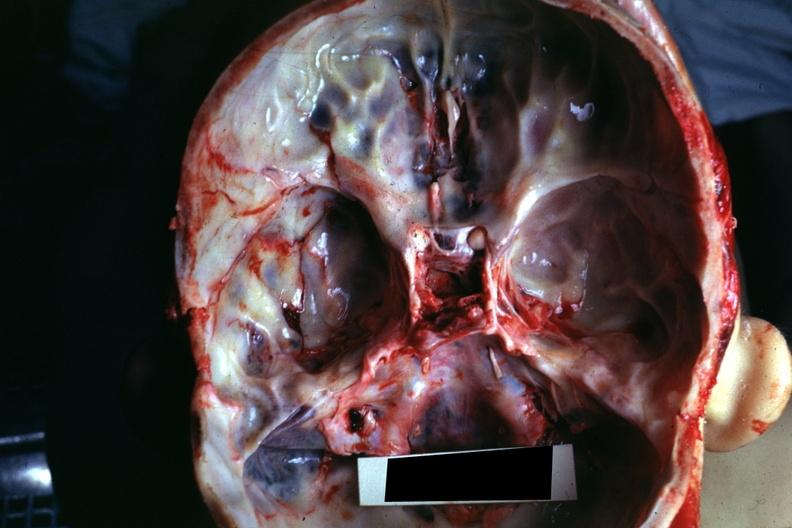what is present?
Answer the question using a single word or phrase. Basilar skull fracture 